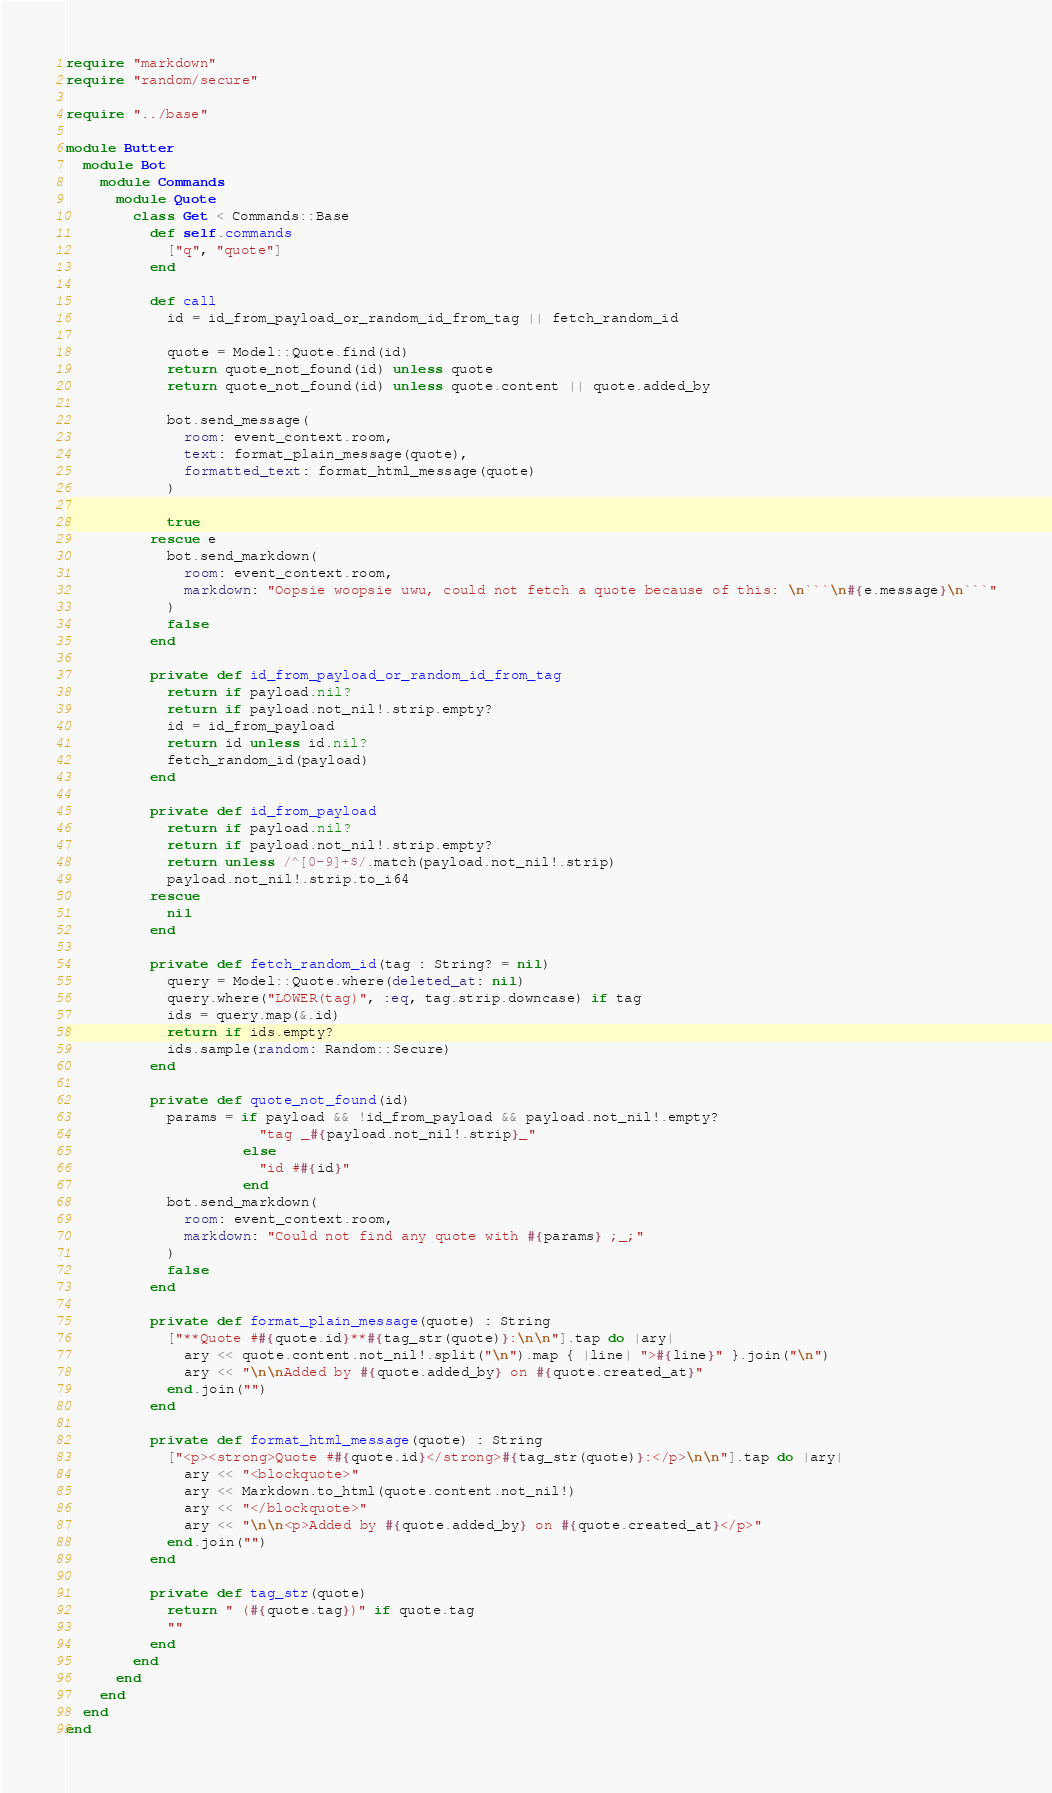Convert code to text. <code><loc_0><loc_0><loc_500><loc_500><_Crystal_>require "markdown"
require "random/secure"

require "../base"

module Butter
  module Bot
    module Commands
      module Quote
        class Get < Commands::Base
          def self.commands
            ["q", "quote"]
          end

          def call
            id = id_from_payload_or_random_id_from_tag || fetch_random_id

            quote = Model::Quote.find(id)
            return quote_not_found(id) unless quote
            return quote_not_found(id) unless quote.content || quote.added_by

            bot.send_message(
              room: event_context.room,
              text: format_plain_message(quote),
              formatted_text: format_html_message(quote)
            )

            true
          rescue e
            bot.send_markdown(
              room: event_context.room,
              markdown: "Oopsie woopsie uwu, could not fetch a quote because of this: \n```\n#{e.message}\n```"
            )
            false
          end

          private def id_from_payload_or_random_id_from_tag
            return if payload.nil?
            return if payload.not_nil!.strip.empty?
            id = id_from_payload
            return id unless id.nil?
            fetch_random_id(payload)
          end

          private def id_from_payload
            return if payload.nil?
            return if payload.not_nil!.strip.empty?
            return unless /^[0-9]+$/.match(payload.not_nil!.strip)
            payload.not_nil!.strip.to_i64
          rescue
            nil
          end

          private def fetch_random_id(tag : String? = nil)
            query = Model::Quote.where(deleted_at: nil)
            query.where("LOWER(tag)", :eq, tag.strip.downcase) if tag
            ids = query.map(&.id)
            return if ids.empty?
            ids.sample(random: Random::Secure)
          end

          private def quote_not_found(id)
            params = if payload && !id_from_payload && payload.not_nil!.empty?
                       "tag _#{payload.not_nil!.strip}_"
                     else
                       "id ##{id}"
                     end
            bot.send_markdown(
              room: event_context.room,
              markdown: "Could not find any quote with #{params} ;_;"
            )
            false
          end

          private def format_plain_message(quote) : String
            ["**Quote ##{quote.id}**#{tag_str(quote)}:\n\n"].tap do |ary|
              ary << quote.content.not_nil!.split("\n").map { |line| ">#{line}" }.join("\n")
              ary << "\n\nAdded by #{quote.added_by} on #{quote.created_at}"
            end.join("")
          end

          private def format_html_message(quote) : String
            ["<p><strong>Quote ##{quote.id}</strong>#{tag_str(quote)}:</p>\n\n"].tap do |ary|
              ary << "<blockquote>"
              ary << Markdown.to_html(quote.content.not_nil!)
              ary << "</blockquote>"
              ary << "\n\n<p>Added by #{quote.added_by} on #{quote.created_at}</p>"
            end.join("")
          end

          private def tag_str(quote)
            return " (#{quote.tag})" if quote.tag
            ""
          end
        end
      end
    end
  end
end
</code> 